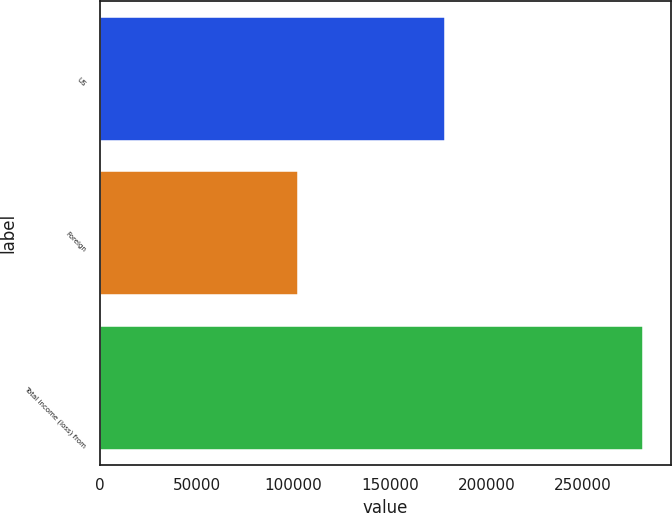Convert chart to OTSL. <chart><loc_0><loc_0><loc_500><loc_500><bar_chart><fcel>US<fcel>Foreign<fcel>Total income (loss) from<nl><fcel>178707<fcel>102583<fcel>281290<nl></chart> 